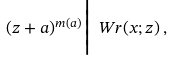<formula> <loc_0><loc_0><loc_500><loc_500>( z + a ) ^ { m ( a ) } \Big | \ W r ( x ; z ) \, ,</formula> 